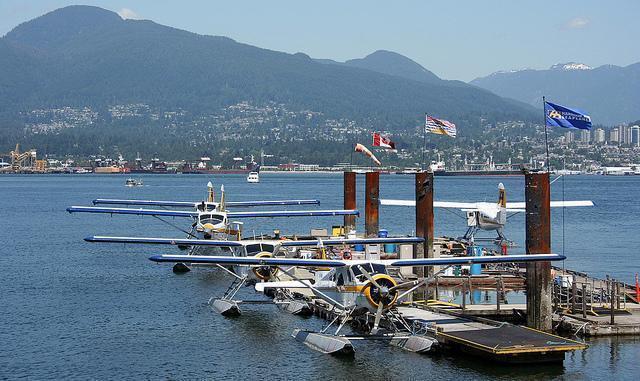What are the planes near the dock called?
Select the accurate answer and provide explanation: 'Answer: answer
Rationale: rationale.'
Options: Airbus, jet, commuter, seaplane. Answer: seaplane.
Rationale: The planes are the kind that can land on the sea and are called seaplanes. 